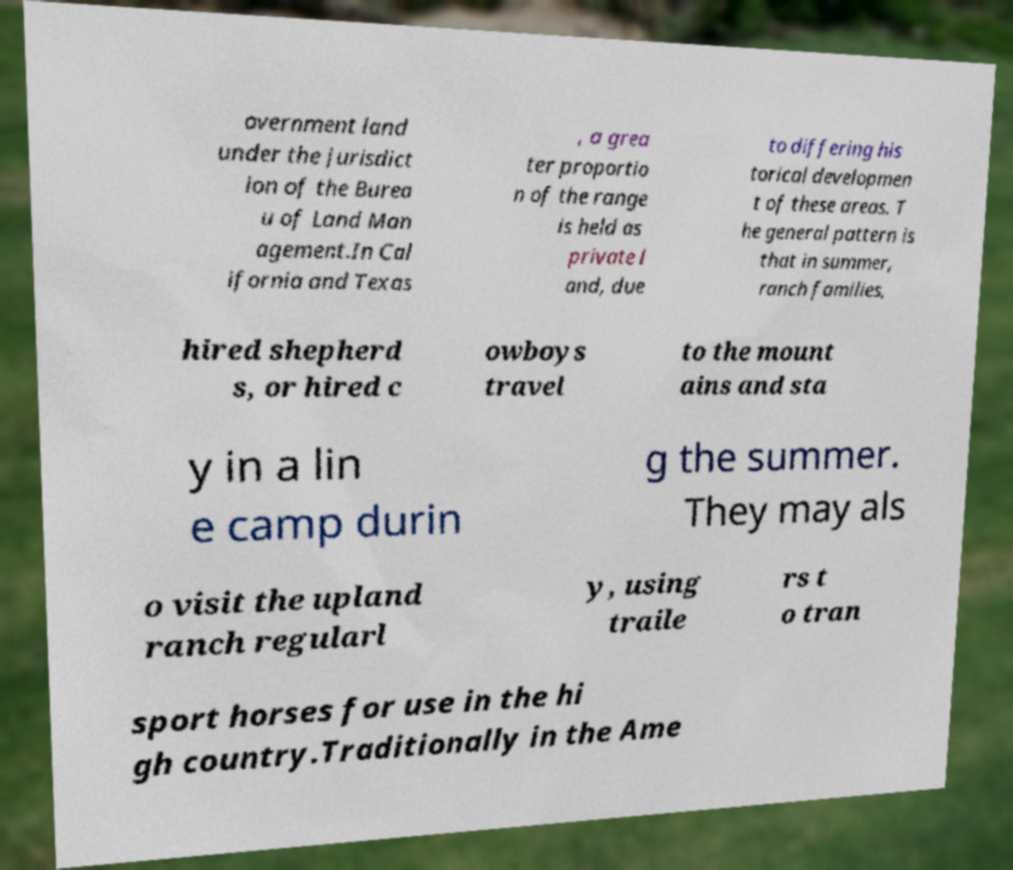What messages or text are displayed in this image? I need them in a readable, typed format. overnment land under the jurisdict ion of the Burea u of Land Man agement.In Cal ifornia and Texas , a grea ter proportio n of the range is held as private l and, due to differing his torical developmen t of these areas. T he general pattern is that in summer, ranch families, hired shepherd s, or hired c owboys travel to the mount ains and sta y in a lin e camp durin g the summer. They may als o visit the upland ranch regularl y, using traile rs t o tran sport horses for use in the hi gh country.Traditionally in the Ame 